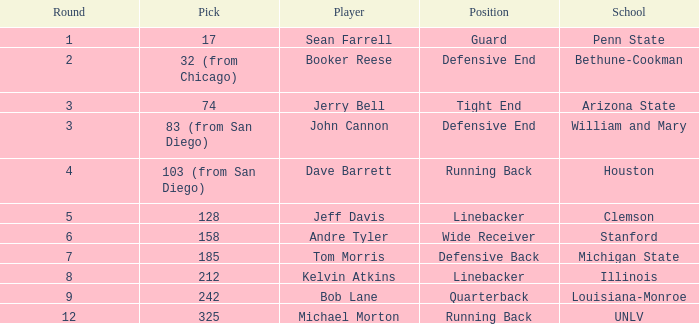In which round does pick number 242 occur? 1.0. 